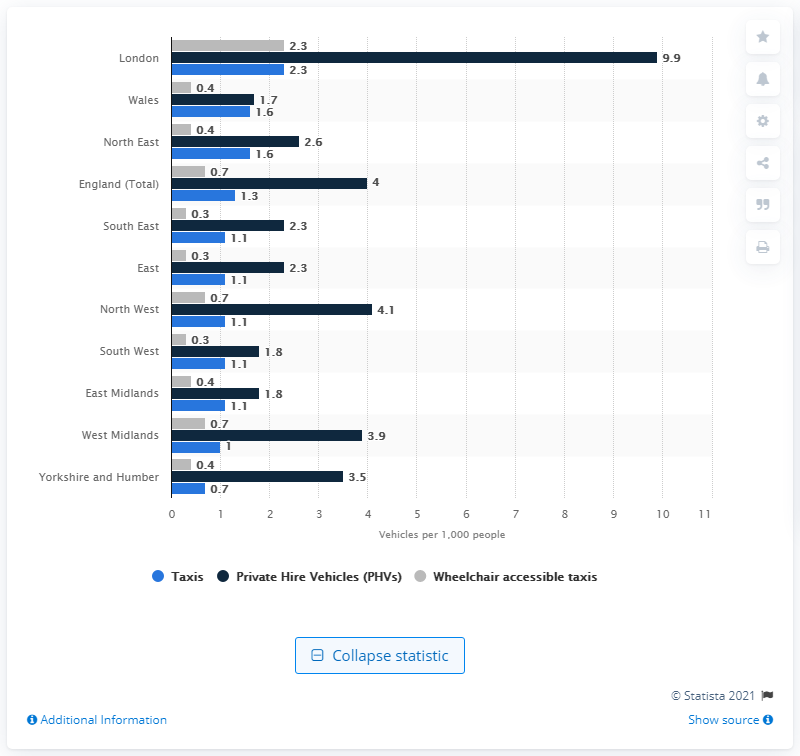Mention a couple of crucial points in this snapshot. In March 2019, there were approximately 2.3 taxis per 1,000 people in London. London had the highest number of taxis. In South East, East England, and the South West, there are approximately 0.3 wheelchair accessible taxis per every 1,000 people. 